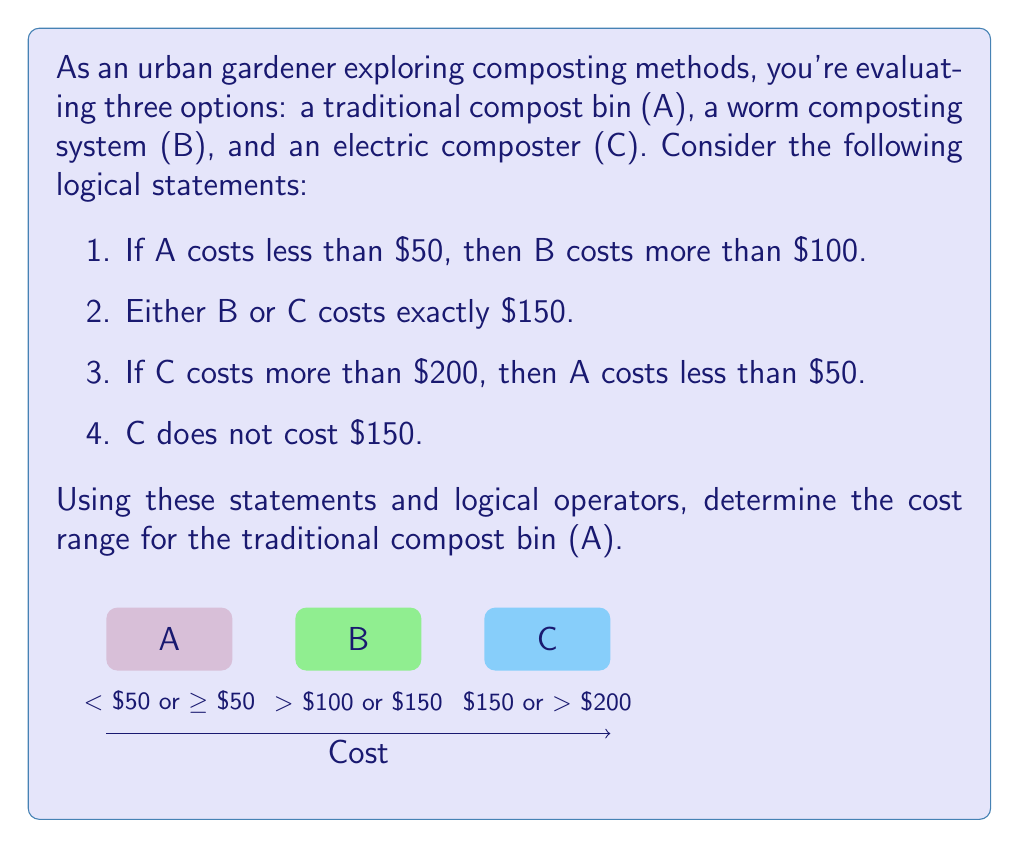Provide a solution to this math problem. Let's approach this step-by-step using logical operators and the given statements:

1. Let's define propositions:
   $p$: A costs less than $50
   $q$: B costs more than $100
   $r$: B costs $150
   $s$: C costs $150
   $t$: C costs more than $200

2. From statement 1: $p \implies q$

3. From statement 2: $r \lor s$

4. From statement 3: $t \implies p$

5. From statement 4: $\neg s$

6. From steps 3 and 5: $r \lor s$ and $\neg s$, therefore $r$ must be true. So, B costs $150.

7. Since B costs $150, it's also true that B costs more than $100. So $q$ is true.

8. From step 2, we know that $p \implies q$. Since $q$ is true (from step 7), we can't determine if $p$ is true or false based on this implication alone.

9. From step 4, $t \implies p$. Since we can't determine $p$, we also can't determine $t$.

10. Therefore, we can conclude that A either costs less than $50 or greater than or equal to $50. We can't narrow it down further with the given information.
Answer: $A < $50 or $A \geq $50 